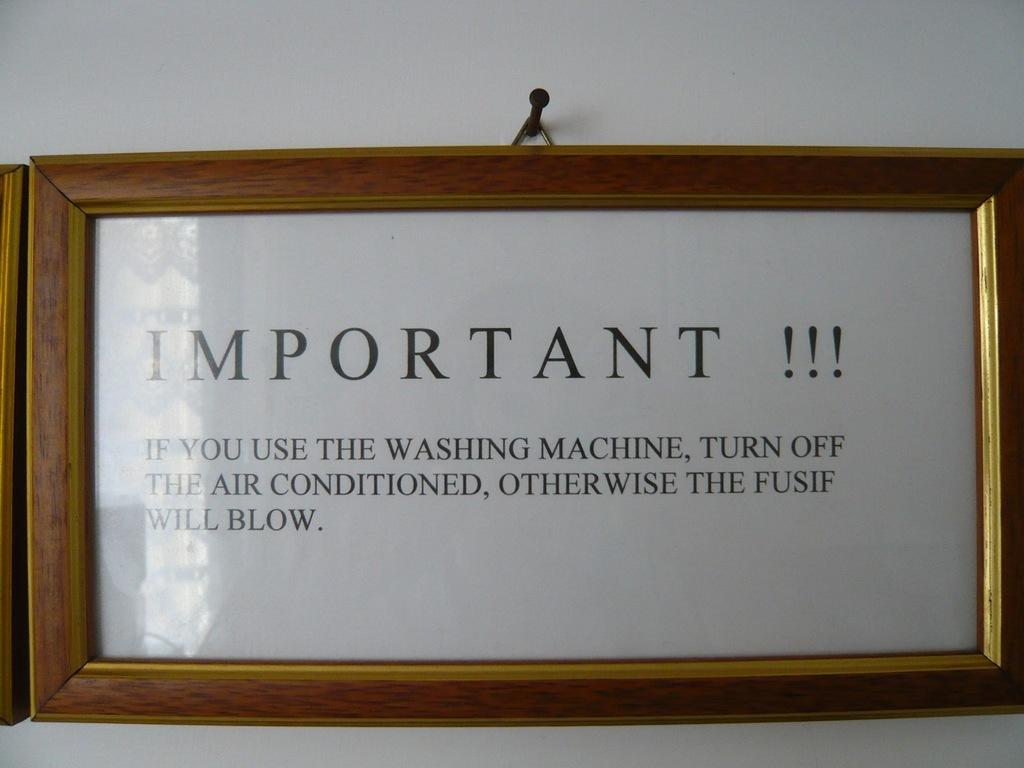<image>
Render a clear and concise summary of the photo. a frame that has the word important on it 